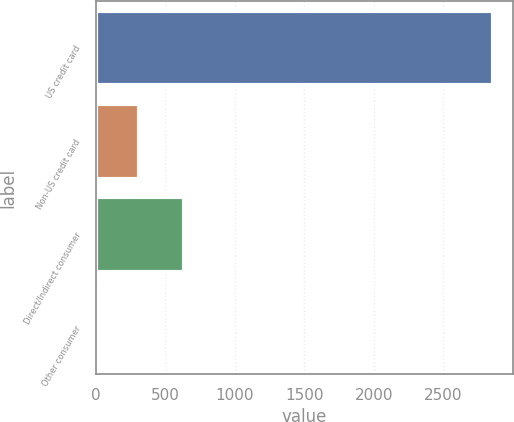Convert chart to OTSL. <chart><loc_0><loc_0><loc_500><loc_500><bar_chart><fcel>US credit card<fcel>Non-US credit card<fcel>Direct/Indirect consumer<fcel>Other consumer<nl><fcel>2856<fcel>312.6<fcel>633<fcel>30<nl></chart> 